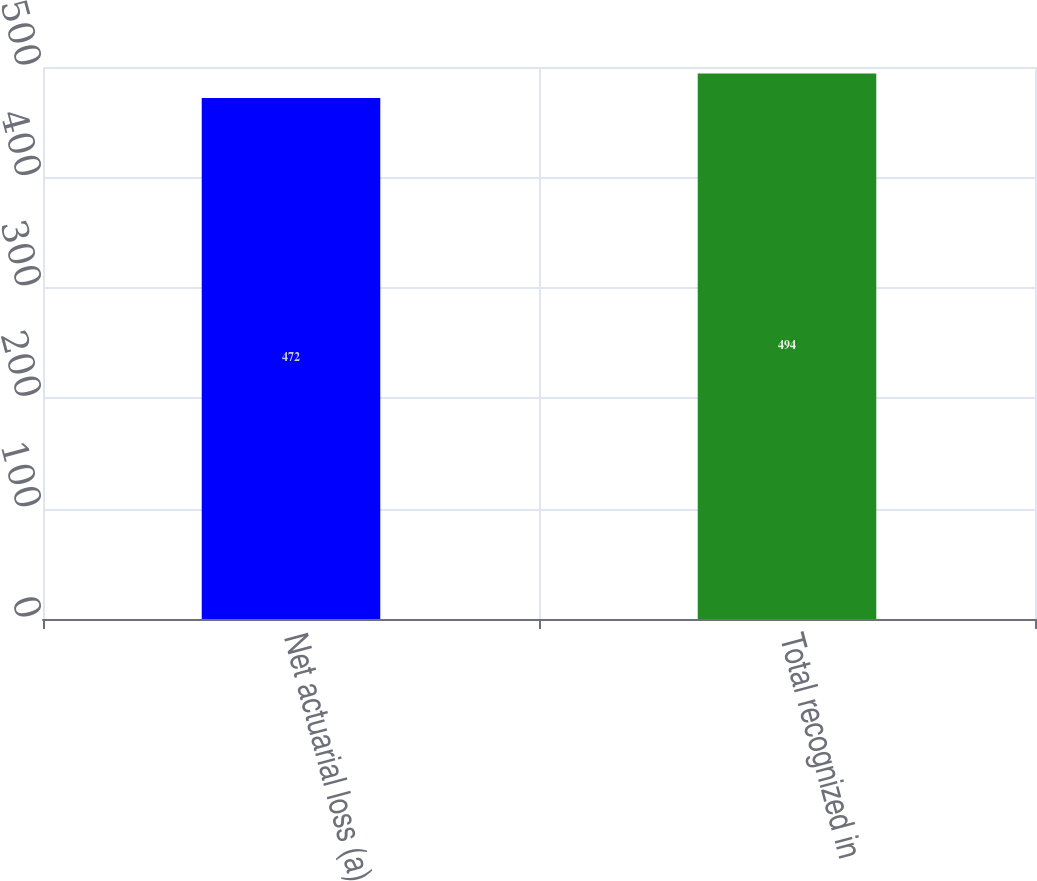<chart> <loc_0><loc_0><loc_500><loc_500><bar_chart><fcel>Net actuarial loss (a)<fcel>Total recognized in<nl><fcel>472<fcel>494<nl></chart> 